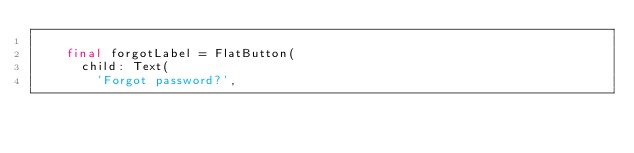Convert code to text. <code><loc_0><loc_0><loc_500><loc_500><_Dart_>
    final forgotLabel = FlatButton(
      child: Text(
        'Forgot password?',</code> 